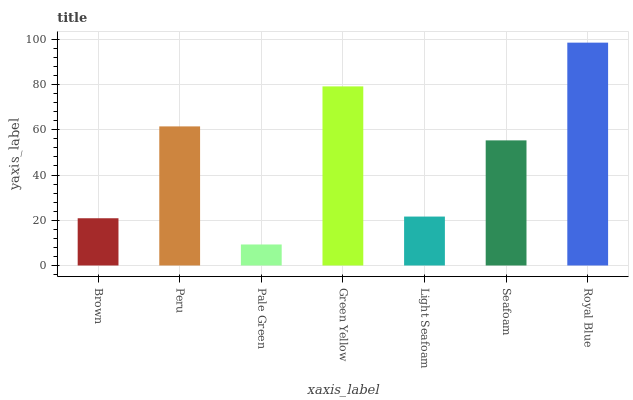Is Pale Green the minimum?
Answer yes or no. Yes. Is Royal Blue the maximum?
Answer yes or no. Yes. Is Peru the minimum?
Answer yes or no. No. Is Peru the maximum?
Answer yes or no. No. Is Peru greater than Brown?
Answer yes or no. Yes. Is Brown less than Peru?
Answer yes or no. Yes. Is Brown greater than Peru?
Answer yes or no. No. Is Peru less than Brown?
Answer yes or no. No. Is Seafoam the high median?
Answer yes or no. Yes. Is Seafoam the low median?
Answer yes or no. Yes. Is Royal Blue the high median?
Answer yes or no. No. Is Royal Blue the low median?
Answer yes or no. No. 